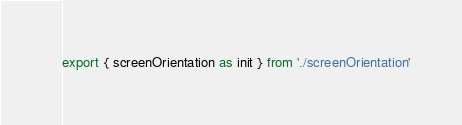Convert code to text. <code><loc_0><loc_0><loc_500><loc_500><_TypeScript_>export { screenOrientation as init } from './screenOrientation'

</code> 